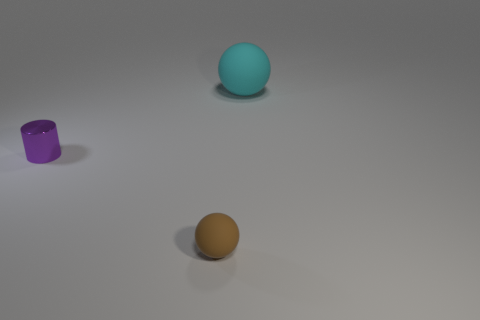Is the cylinder made of the same material as the tiny ball right of the purple object?
Your response must be concise. No. Is there anything else that has the same color as the big thing?
Give a very brief answer. No. Is there a small metal object to the left of the rubber sphere behind the matte ball in front of the cyan ball?
Offer a very short reply. Yes. What is the color of the shiny object?
Provide a short and direct response. Purple. There is a tiny sphere; are there any large cyan rubber spheres in front of it?
Offer a terse response. No. Do the tiny brown object and the tiny thing that is on the left side of the tiny brown object have the same shape?
Provide a succinct answer. No. What number of other objects are there of the same material as the brown object?
Ensure brevity in your answer.  1. What is the color of the rubber thing that is in front of the matte sphere behind the tiny matte ball that is in front of the cyan ball?
Provide a short and direct response. Brown. The thing that is left of the ball on the left side of the large cyan object is what shape?
Offer a terse response. Cylinder. Are there more large rubber things in front of the brown sphere than small purple metal cylinders?
Make the answer very short. No. 